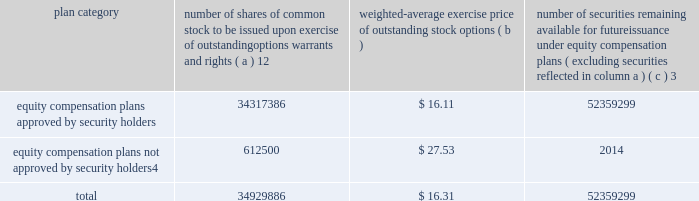Part iii item 10 .
Directors , executive officers and corporate governance the information required by this item is incorporated by reference to the 201celection of directors 201d section , the 201cdirector selection process 201d section , the 201ccode of conduct 201d section , the 201cprincipal committees of the board of directors 201d section , the 201caudit committee 201d section and the 201csection 16 ( a ) beneficial ownership reporting compliance 201d section of the proxy statement for the annual meeting of stockholders to be held on may 27 , 2010 ( the 201cproxy statement 201d ) , except for the description of our executive officers , which appears in part i of this report on form 10-k under the heading 201cexecutive officers of ipg . 201d new york stock exchange certification in 2009 , our ceo provided the annual ceo certification to the new york stock exchange , as required under section 303a.12 ( a ) of the new york stock exchange listed company manual .
Item 11 .
Executive compensation the information required by this item is incorporated by reference to the 201ccompensation of executive officers 201d section , the 201cnon-management director compensation 201d section , the 201ccompensation discussion and analysis 201d section and the 201ccompensation committee report 201d section of the proxy statement .
Item 12 .
Security ownership of certain beneficial owners and management and related stockholder matters the information required by this item is incorporated by reference to the 201coutstanding shares 201d section of the proxy statement , except for information regarding the shares of common stock to be issued or which may be issued under our equity compensation plans as of december 31 , 2009 , which is provided in the table .
Equity compensation plan information plan category number of shares of common stock to be issued upon exercise of outstanding options , warrants and rights ( a ) 12 weighted-average exercise price of outstanding stock options ( b ) number of securities remaining available for future issuance under equity compensation plans ( excluding securities reflected in column a ) ( c ) 3 equity compensation plans approved by security holders .
34317386 $ 16.11 52359299 equity compensation plans not approved by security holders 4 .
612500 $ 27.53 2014 .
1 includes a total of 6058967 performance-based share awards made under the 2004 , 2006 and 2009 performance incentive plan representing the target number of shares to be issued to employees following the completion of the 2007-2009 performance period ( the 201c2009 ltip share awards 201d ) , the 2008- 2010 performance period ( the 201c2010 ltip share awards 201d ) and the 2009-2011 performance period ( the 201c2011 ltip share awards 201d ) respectively .
The computation of the weighted-average exercise price in column ( b ) of this table does not take the 2009 ltip share awards , the 2010 ltip share awards or the 2011 ltip share awards into account .
2 includes a total of 3914804 restricted share unit and performance-based awards ( 201cshare unit awards 201d ) which may be settled in shares or cash .
The computation of the weighted-average exercise price in column ( b ) of this table does not take the share unit awards into account .
Each share unit award actually settled in cash will increase the number of shares of common stock available for issuance shown in column ( c ) .
3 includes ( i ) 37885502 shares of common stock available for issuance under the 2009 performance incentive plan , ( ii ) 13660306 shares of common stock available for issuance under the employee stock purchase plan ( 2006 ) and ( iii ) 813491 shares of common stock available for issuance under the 2009 non-management directors 2019 stock incentive plan .
4 consists of special stock option grants awarded to certain true north executives following our acquisition of true north ( the 201ctrue north options 201d ) .
The true north options have an exercise price equal to the fair market value of interpublic 2019s common stock on the date of the grant .
The terms and conditions of these stock option awards are governed by interpublic 2019s 1997 performance incentive plan .
Generally , the options become exercisable between two and five years after the date of the grant and expire ten years from the grant date. .
What was the total number of equity compensation plans approved by security holders? 
Computations: (34317386 + 52359299)
Answer: 86676685.0. 